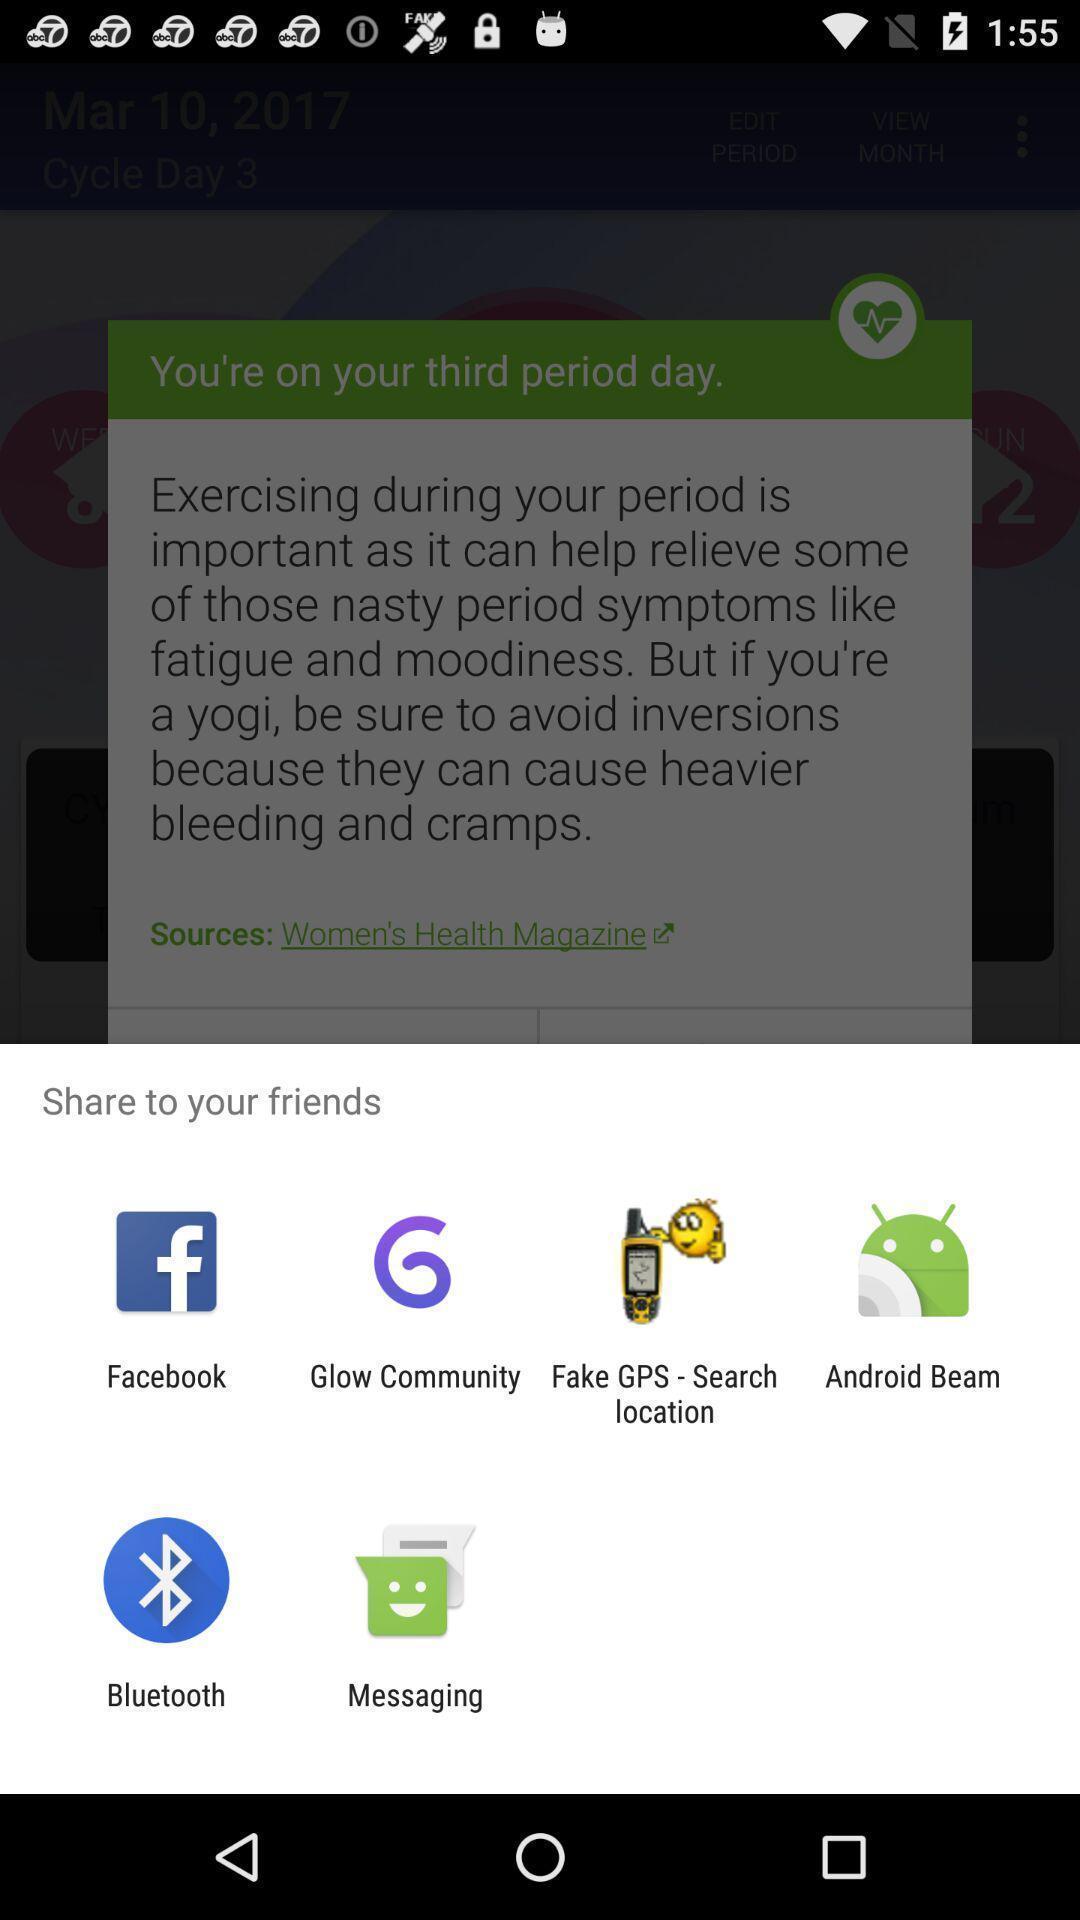Summarize the main components in this picture. Share page to select through which app to complete action. 